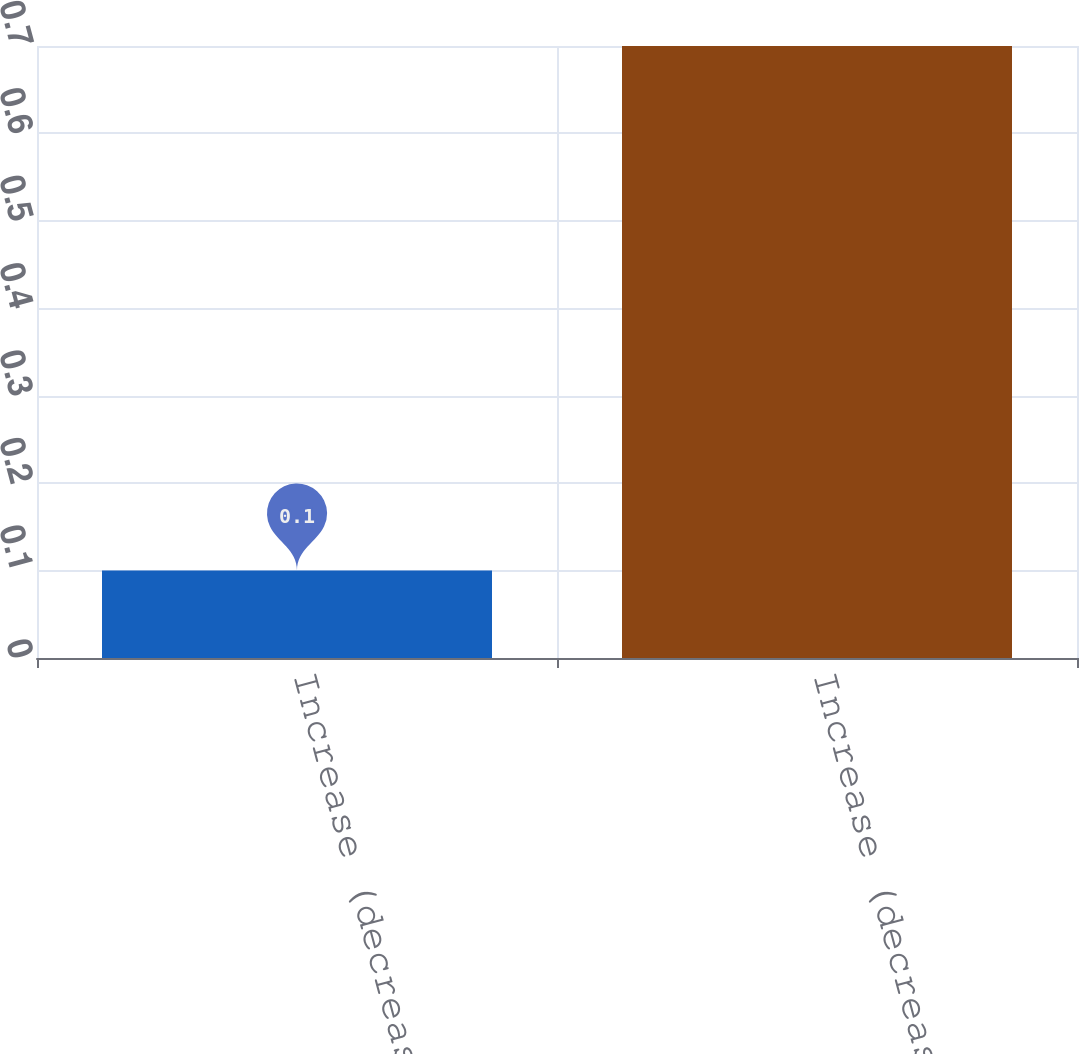<chart> <loc_0><loc_0><loc_500><loc_500><bar_chart><fcel>Increase (decrease) in annual<fcel>Increase (decrease) in other<nl><fcel>0.1<fcel>0.7<nl></chart> 